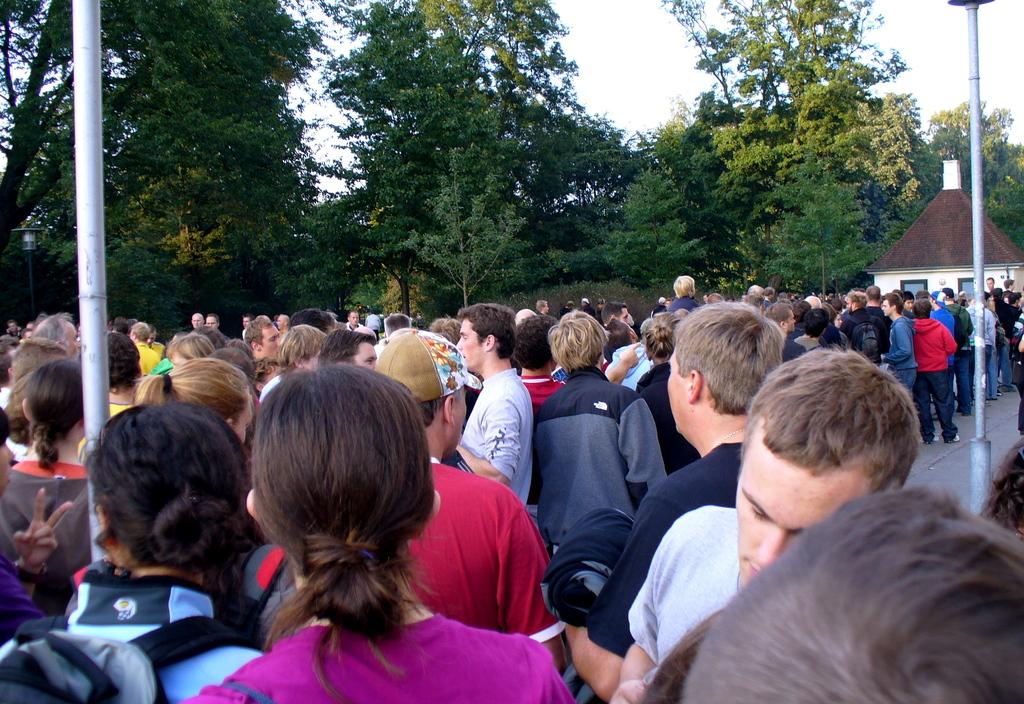How many people are visible in the image? There are many people standing in the image. What are the people wearing? The people are wearing clothes. What are some people carrying on their backs? Some people are carrying bags on their backs. What can be seen in the image besides the people? There is a pole, a footpath, a house, and trees in the image. What is the color of the sky in the image? The sky is white in the image. What grade is the jar being used for in the image? There is no jar present in the image, so it cannot be used for any grade. Is there a bed visible in the image? No, there is no bed visible in the image. 